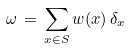Convert formula to latex. <formula><loc_0><loc_0><loc_500><loc_500>\omega \, = \, \sum _ { x \in S } w ( x ) \, \delta _ { x }</formula> 